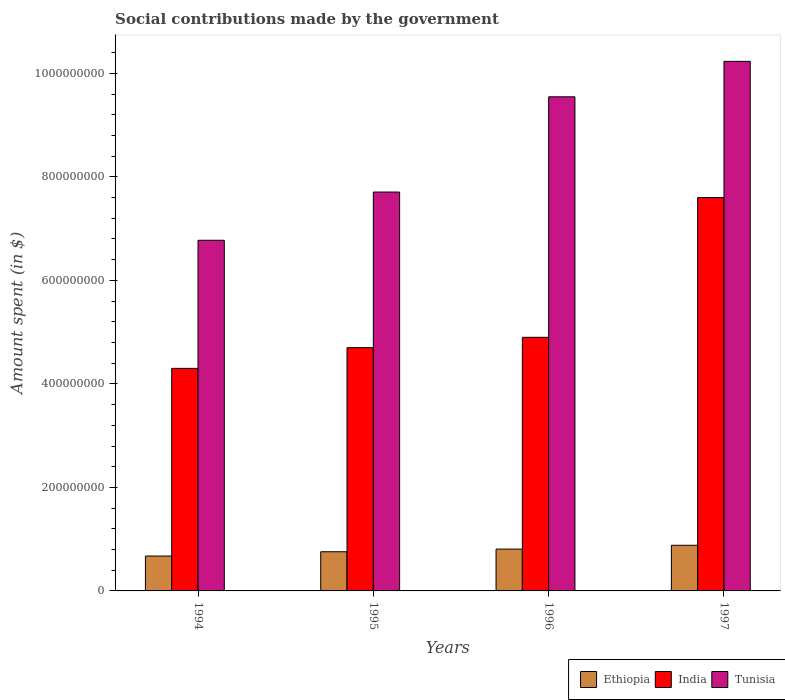Are the number of bars per tick equal to the number of legend labels?
Provide a short and direct response. Yes. In how many cases, is the number of bars for a given year not equal to the number of legend labels?
Make the answer very short. 0. What is the amount spent on social contributions in Ethiopia in 1997?
Provide a succinct answer. 8.82e+07. Across all years, what is the maximum amount spent on social contributions in Ethiopia?
Your answer should be compact. 8.82e+07. Across all years, what is the minimum amount spent on social contributions in Tunisia?
Your answer should be compact. 6.78e+08. In which year was the amount spent on social contributions in Tunisia maximum?
Provide a succinct answer. 1997. In which year was the amount spent on social contributions in Tunisia minimum?
Make the answer very short. 1994. What is the total amount spent on social contributions in Tunisia in the graph?
Ensure brevity in your answer.  3.43e+09. What is the difference between the amount spent on social contributions in Tunisia in 1995 and that in 1996?
Make the answer very short. -1.84e+08. What is the difference between the amount spent on social contributions in Ethiopia in 1997 and the amount spent on social contributions in India in 1996?
Your response must be concise. -4.02e+08. What is the average amount spent on social contributions in India per year?
Your answer should be very brief. 5.38e+08. In the year 1996, what is the difference between the amount spent on social contributions in India and amount spent on social contributions in Ethiopia?
Offer a very short reply. 4.09e+08. What is the ratio of the amount spent on social contributions in Ethiopia in 1994 to that in 1995?
Give a very brief answer. 0.89. What is the difference between the highest and the second highest amount spent on social contributions in Tunisia?
Make the answer very short. 6.85e+07. What is the difference between the highest and the lowest amount spent on social contributions in India?
Offer a terse response. 3.30e+08. Is the sum of the amount spent on social contributions in India in 1995 and 1996 greater than the maximum amount spent on social contributions in Tunisia across all years?
Your answer should be very brief. No. What does the 2nd bar from the left in 1994 represents?
Ensure brevity in your answer.  India. What does the 3rd bar from the right in 1996 represents?
Offer a terse response. Ethiopia. Is it the case that in every year, the sum of the amount spent on social contributions in India and amount spent on social contributions in Tunisia is greater than the amount spent on social contributions in Ethiopia?
Provide a succinct answer. Yes. How many bars are there?
Provide a succinct answer. 12. How many years are there in the graph?
Your answer should be very brief. 4. Where does the legend appear in the graph?
Provide a succinct answer. Bottom right. How many legend labels are there?
Your response must be concise. 3. How are the legend labels stacked?
Offer a very short reply. Horizontal. What is the title of the graph?
Make the answer very short. Social contributions made by the government. Does "Hungary" appear as one of the legend labels in the graph?
Provide a succinct answer. No. What is the label or title of the Y-axis?
Offer a very short reply. Amount spent (in $). What is the Amount spent (in $) in Ethiopia in 1994?
Give a very brief answer. 6.74e+07. What is the Amount spent (in $) of India in 1994?
Your answer should be compact. 4.30e+08. What is the Amount spent (in $) in Tunisia in 1994?
Provide a short and direct response. 6.78e+08. What is the Amount spent (in $) in Ethiopia in 1995?
Keep it short and to the point. 7.57e+07. What is the Amount spent (in $) in India in 1995?
Offer a very short reply. 4.70e+08. What is the Amount spent (in $) in Tunisia in 1995?
Keep it short and to the point. 7.71e+08. What is the Amount spent (in $) of Ethiopia in 1996?
Ensure brevity in your answer.  8.08e+07. What is the Amount spent (in $) in India in 1996?
Provide a succinct answer. 4.90e+08. What is the Amount spent (in $) in Tunisia in 1996?
Keep it short and to the point. 9.55e+08. What is the Amount spent (in $) in Ethiopia in 1997?
Provide a short and direct response. 8.82e+07. What is the Amount spent (in $) in India in 1997?
Ensure brevity in your answer.  7.60e+08. What is the Amount spent (in $) of Tunisia in 1997?
Provide a short and direct response. 1.02e+09. Across all years, what is the maximum Amount spent (in $) of Ethiopia?
Keep it short and to the point. 8.82e+07. Across all years, what is the maximum Amount spent (in $) in India?
Keep it short and to the point. 7.60e+08. Across all years, what is the maximum Amount spent (in $) of Tunisia?
Make the answer very short. 1.02e+09. Across all years, what is the minimum Amount spent (in $) of Ethiopia?
Make the answer very short. 6.74e+07. Across all years, what is the minimum Amount spent (in $) in India?
Provide a short and direct response. 4.30e+08. Across all years, what is the minimum Amount spent (in $) in Tunisia?
Ensure brevity in your answer.  6.78e+08. What is the total Amount spent (in $) of Ethiopia in the graph?
Keep it short and to the point. 3.12e+08. What is the total Amount spent (in $) of India in the graph?
Make the answer very short. 2.15e+09. What is the total Amount spent (in $) in Tunisia in the graph?
Your answer should be compact. 3.43e+09. What is the difference between the Amount spent (in $) in Ethiopia in 1994 and that in 1995?
Your answer should be compact. -8.30e+06. What is the difference between the Amount spent (in $) in India in 1994 and that in 1995?
Make the answer very short. -4.00e+07. What is the difference between the Amount spent (in $) of Tunisia in 1994 and that in 1995?
Offer a terse response. -9.32e+07. What is the difference between the Amount spent (in $) of Ethiopia in 1994 and that in 1996?
Ensure brevity in your answer.  -1.34e+07. What is the difference between the Amount spent (in $) in India in 1994 and that in 1996?
Offer a very short reply. -6.00e+07. What is the difference between the Amount spent (in $) in Tunisia in 1994 and that in 1996?
Make the answer very short. -2.77e+08. What is the difference between the Amount spent (in $) of Ethiopia in 1994 and that in 1997?
Provide a short and direct response. -2.08e+07. What is the difference between the Amount spent (in $) of India in 1994 and that in 1997?
Give a very brief answer. -3.30e+08. What is the difference between the Amount spent (in $) of Tunisia in 1994 and that in 1997?
Provide a short and direct response. -3.46e+08. What is the difference between the Amount spent (in $) of Ethiopia in 1995 and that in 1996?
Your answer should be compact. -5.10e+06. What is the difference between the Amount spent (in $) of India in 1995 and that in 1996?
Keep it short and to the point. -2.00e+07. What is the difference between the Amount spent (in $) in Tunisia in 1995 and that in 1996?
Give a very brief answer. -1.84e+08. What is the difference between the Amount spent (in $) in Ethiopia in 1995 and that in 1997?
Give a very brief answer. -1.25e+07. What is the difference between the Amount spent (in $) in India in 1995 and that in 1997?
Offer a very short reply. -2.90e+08. What is the difference between the Amount spent (in $) of Tunisia in 1995 and that in 1997?
Provide a short and direct response. -2.52e+08. What is the difference between the Amount spent (in $) in Ethiopia in 1996 and that in 1997?
Keep it short and to the point. -7.40e+06. What is the difference between the Amount spent (in $) of India in 1996 and that in 1997?
Ensure brevity in your answer.  -2.70e+08. What is the difference between the Amount spent (in $) of Tunisia in 1996 and that in 1997?
Your response must be concise. -6.85e+07. What is the difference between the Amount spent (in $) of Ethiopia in 1994 and the Amount spent (in $) of India in 1995?
Give a very brief answer. -4.03e+08. What is the difference between the Amount spent (in $) in Ethiopia in 1994 and the Amount spent (in $) in Tunisia in 1995?
Make the answer very short. -7.03e+08. What is the difference between the Amount spent (in $) of India in 1994 and the Amount spent (in $) of Tunisia in 1995?
Provide a succinct answer. -3.41e+08. What is the difference between the Amount spent (in $) in Ethiopia in 1994 and the Amount spent (in $) in India in 1996?
Offer a terse response. -4.23e+08. What is the difference between the Amount spent (in $) in Ethiopia in 1994 and the Amount spent (in $) in Tunisia in 1996?
Make the answer very short. -8.87e+08. What is the difference between the Amount spent (in $) in India in 1994 and the Amount spent (in $) in Tunisia in 1996?
Your answer should be very brief. -5.25e+08. What is the difference between the Amount spent (in $) of Ethiopia in 1994 and the Amount spent (in $) of India in 1997?
Offer a very short reply. -6.93e+08. What is the difference between the Amount spent (in $) in Ethiopia in 1994 and the Amount spent (in $) in Tunisia in 1997?
Offer a terse response. -9.56e+08. What is the difference between the Amount spent (in $) of India in 1994 and the Amount spent (in $) of Tunisia in 1997?
Ensure brevity in your answer.  -5.93e+08. What is the difference between the Amount spent (in $) of Ethiopia in 1995 and the Amount spent (in $) of India in 1996?
Give a very brief answer. -4.14e+08. What is the difference between the Amount spent (in $) in Ethiopia in 1995 and the Amount spent (in $) in Tunisia in 1996?
Your answer should be very brief. -8.79e+08. What is the difference between the Amount spent (in $) in India in 1995 and the Amount spent (in $) in Tunisia in 1996?
Make the answer very short. -4.85e+08. What is the difference between the Amount spent (in $) of Ethiopia in 1995 and the Amount spent (in $) of India in 1997?
Ensure brevity in your answer.  -6.84e+08. What is the difference between the Amount spent (in $) in Ethiopia in 1995 and the Amount spent (in $) in Tunisia in 1997?
Your response must be concise. -9.48e+08. What is the difference between the Amount spent (in $) in India in 1995 and the Amount spent (in $) in Tunisia in 1997?
Provide a short and direct response. -5.53e+08. What is the difference between the Amount spent (in $) of Ethiopia in 1996 and the Amount spent (in $) of India in 1997?
Provide a succinct answer. -6.79e+08. What is the difference between the Amount spent (in $) of Ethiopia in 1996 and the Amount spent (in $) of Tunisia in 1997?
Provide a short and direct response. -9.42e+08. What is the difference between the Amount spent (in $) of India in 1996 and the Amount spent (in $) of Tunisia in 1997?
Your response must be concise. -5.33e+08. What is the average Amount spent (in $) in Ethiopia per year?
Provide a succinct answer. 7.80e+07. What is the average Amount spent (in $) of India per year?
Your answer should be compact. 5.38e+08. What is the average Amount spent (in $) of Tunisia per year?
Offer a terse response. 8.57e+08. In the year 1994, what is the difference between the Amount spent (in $) of Ethiopia and Amount spent (in $) of India?
Your response must be concise. -3.63e+08. In the year 1994, what is the difference between the Amount spent (in $) in Ethiopia and Amount spent (in $) in Tunisia?
Offer a very short reply. -6.10e+08. In the year 1994, what is the difference between the Amount spent (in $) of India and Amount spent (in $) of Tunisia?
Your answer should be very brief. -2.48e+08. In the year 1995, what is the difference between the Amount spent (in $) of Ethiopia and Amount spent (in $) of India?
Give a very brief answer. -3.94e+08. In the year 1995, what is the difference between the Amount spent (in $) of Ethiopia and Amount spent (in $) of Tunisia?
Your answer should be compact. -6.95e+08. In the year 1995, what is the difference between the Amount spent (in $) of India and Amount spent (in $) of Tunisia?
Keep it short and to the point. -3.01e+08. In the year 1996, what is the difference between the Amount spent (in $) in Ethiopia and Amount spent (in $) in India?
Offer a very short reply. -4.09e+08. In the year 1996, what is the difference between the Amount spent (in $) of Ethiopia and Amount spent (in $) of Tunisia?
Offer a very short reply. -8.74e+08. In the year 1996, what is the difference between the Amount spent (in $) of India and Amount spent (in $) of Tunisia?
Offer a very short reply. -4.65e+08. In the year 1997, what is the difference between the Amount spent (in $) of Ethiopia and Amount spent (in $) of India?
Ensure brevity in your answer.  -6.72e+08. In the year 1997, what is the difference between the Amount spent (in $) of Ethiopia and Amount spent (in $) of Tunisia?
Offer a terse response. -9.35e+08. In the year 1997, what is the difference between the Amount spent (in $) of India and Amount spent (in $) of Tunisia?
Your answer should be very brief. -2.63e+08. What is the ratio of the Amount spent (in $) in Ethiopia in 1994 to that in 1995?
Offer a terse response. 0.89. What is the ratio of the Amount spent (in $) in India in 1994 to that in 1995?
Your answer should be very brief. 0.91. What is the ratio of the Amount spent (in $) in Tunisia in 1994 to that in 1995?
Offer a very short reply. 0.88. What is the ratio of the Amount spent (in $) of Ethiopia in 1994 to that in 1996?
Offer a very short reply. 0.83. What is the ratio of the Amount spent (in $) of India in 1994 to that in 1996?
Provide a short and direct response. 0.88. What is the ratio of the Amount spent (in $) in Tunisia in 1994 to that in 1996?
Your answer should be compact. 0.71. What is the ratio of the Amount spent (in $) in Ethiopia in 1994 to that in 1997?
Provide a succinct answer. 0.76. What is the ratio of the Amount spent (in $) of India in 1994 to that in 1997?
Ensure brevity in your answer.  0.57. What is the ratio of the Amount spent (in $) in Tunisia in 1994 to that in 1997?
Offer a terse response. 0.66. What is the ratio of the Amount spent (in $) in Ethiopia in 1995 to that in 1996?
Make the answer very short. 0.94. What is the ratio of the Amount spent (in $) of India in 1995 to that in 1996?
Ensure brevity in your answer.  0.96. What is the ratio of the Amount spent (in $) of Tunisia in 1995 to that in 1996?
Provide a short and direct response. 0.81. What is the ratio of the Amount spent (in $) of Ethiopia in 1995 to that in 1997?
Keep it short and to the point. 0.86. What is the ratio of the Amount spent (in $) of India in 1995 to that in 1997?
Make the answer very short. 0.62. What is the ratio of the Amount spent (in $) of Tunisia in 1995 to that in 1997?
Ensure brevity in your answer.  0.75. What is the ratio of the Amount spent (in $) in Ethiopia in 1996 to that in 1997?
Your response must be concise. 0.92. What is the ratio of the Amount spent (in $) of India in 1996 to that in 1997?
Keep it short and to the point. 0.64. What is the ratio of the Amount spent (in $) of Tunisia in 1996 to that in 1997?
Ensure brevity in your answer.  0.93. What is the difference between the highest and the second highest Amount spent (in $) of Ethiopia?
Give a very brief answer. 7.40e+06. What is the difference between the highest and the second highest Amount spent (in $) of India?
Ensure brevity in your answer.  2.70e+08. What is the difference between the highest and the second highest Amount spent (in $) in Tunisia?
Keep it short and to the point. 6.85e+07. What is the difference between the highest and the lowest Amount spent (in $) in Ethiopia?
Your answer should be very brief. 2.08e+07. What is the difference between the highest and the lowest Amount spent (in $) in India?
Your answer should be very brief. 3.30e+08. What is the difference between the highest and the lowest Amount spent (in $) in Tunisia?
Your response must be concise. 3.46e+08. 